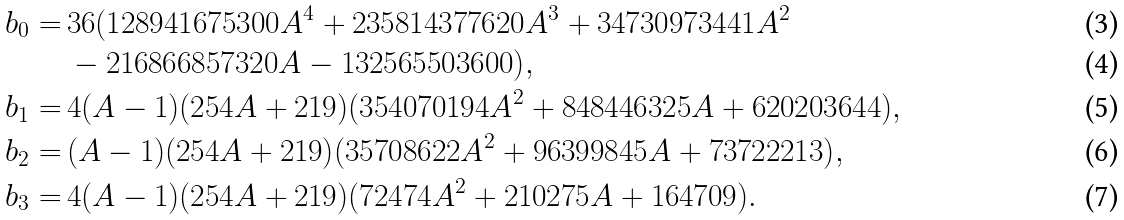<formula> <loc_0><loc_0><loc_500><loc_500>b _ { 0 } = & \, 3 6 ( 1 2 8 9 4 1 6 7 5 3 0 0 A ^ { 4 } + 2 3 5 8 1 4 3 7 7 6 2 0 A ^ { 3 } + 3 4 7 3 0 9 7 3 4 4 1 A ^ { 2 } \\ & \, - 2 1 6 8 6 6 8 5 7 3 2 0 A - 1 3 2 5 6 5 5 0 3 6 0 0 ) , \\ b _ { 1 } = & \, 4 ( A - 1 ) ( 2 5 4 A + 2 1 9 ) ( 3 5 4 0 7 0 1 9 4 A ^ { 2 } + 8 4 8 4 4 6 3 2 5 A + 6 2 0 2 0 3 6 4 4 ) , \\ b _ { 2 } = & \, ( A - 1 ) ( 2 5 4 A + 2 1 9 ) ( 3 5 7 0 8 6 2 2 A ^ { 2 } + 9 6 3 9 9 8 4 5 A + 7 3 7 2 2 2 1 3 ) , \\ b _ { 3 } = & \, 4 ( A - 1 ) ( 2 5 4 A + 2 1 9 ) ( 7 2 4 7 4 A ^ { 2 } + 2 1 0 2 7 5 A + 1 6 4 7 0 9 ) .</formula> 